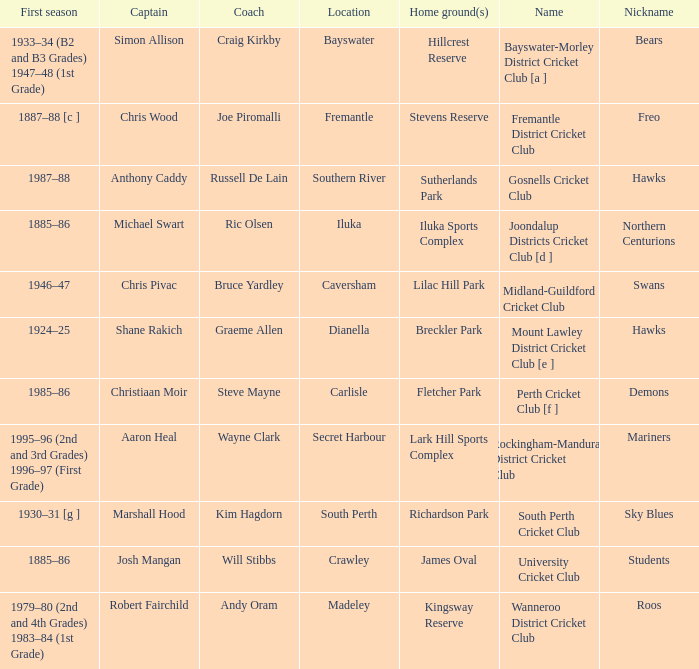What is the location for the club with the nickname the bears? Bayswater. 